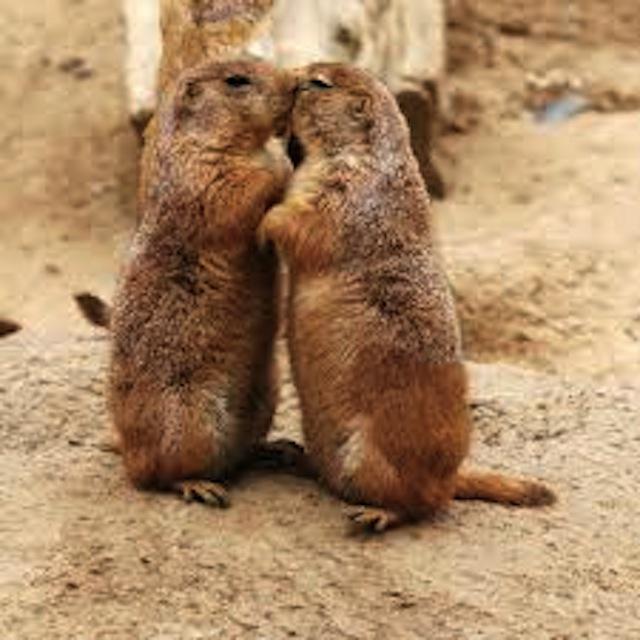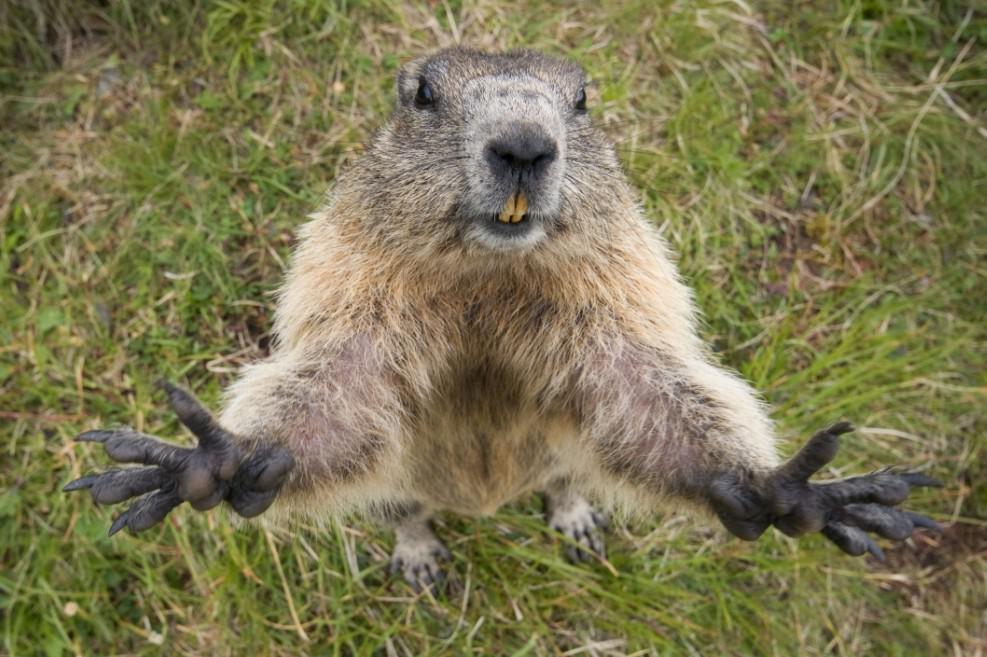The first image is the image on the left, the second image is the image on the right. Analyze the images presented: Is the assertion "there are at least two animals eating in the image on the right." valid? Answer yes or no. No. The first image is the image on the left, the second image is the image on the right. For the images shown, is this caption "Two marmots are in contact in a nuzzling pose in one image." true? Answer yes or no. Yes. 